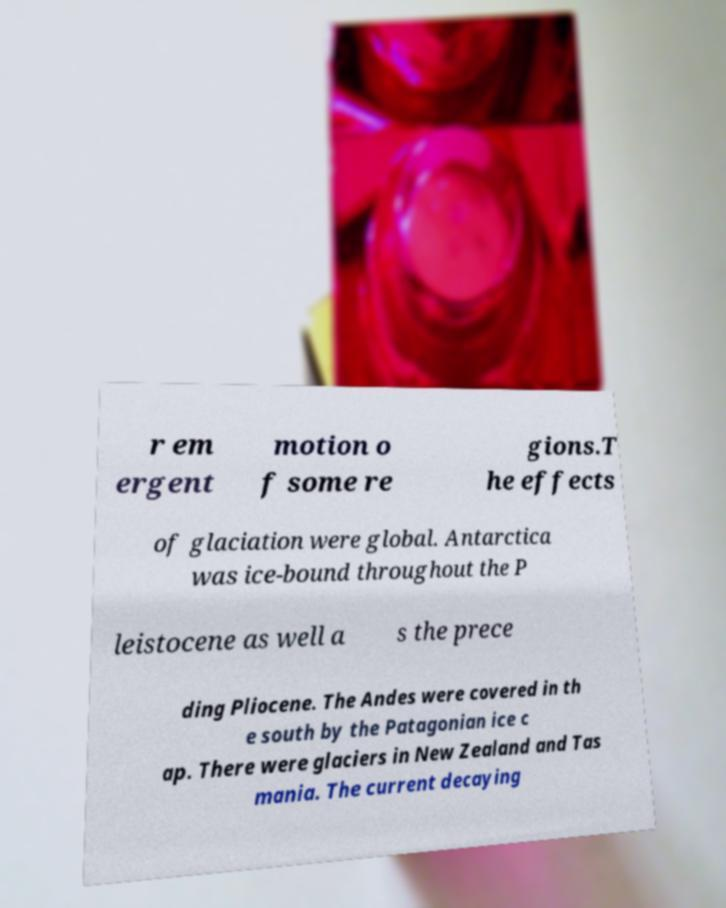Please read and relay the text visible in this image. What does it say? r em ergent motion o f some re gions.T he effects of glaciation were global. Antarctica was ice-bound throughout the P leistocene as well a s the prece ding Pliocene. The Andes were covered in th e south by the Patagonian ice c ap. There were glaciers in New Zealand and Tas mania. The current decaying 